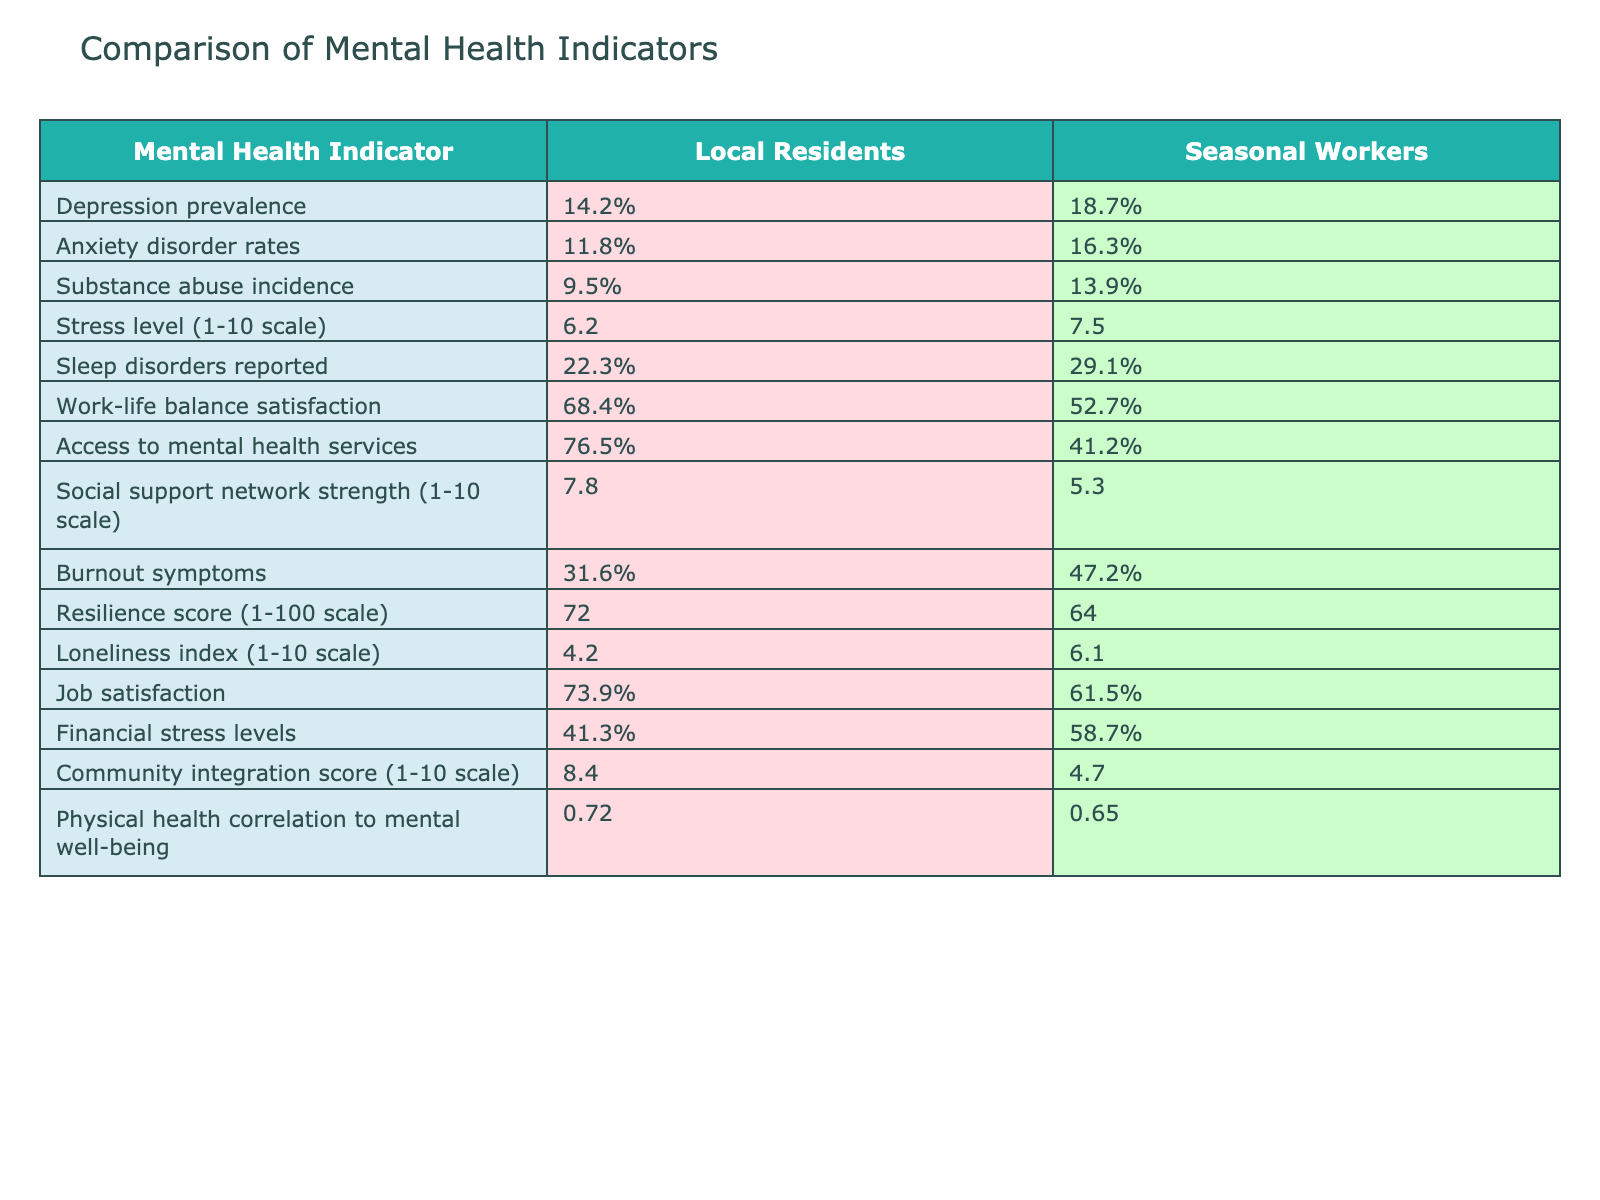What is the prevalence of depression among local residents? The table states that the prevalence of depression among local residents is 14.2%.
Answer: 14.2% What percentage of seasonal workers report sleep disorders? According to the table, 29.1% of seasonal workers report sleep disorders.
Answer: 29.1% Is the anxiety disorder rate higher for seasonal workers than local residents? Yes, seasonal workers have an anxiety disorder rate of 16.3%, which is higher than the 11.8% for local residents.
Answer: Yes What is the difference in work-life balance satisfaction between local residents and seasonal workers? Local residents have a work-life balance satisfaction of 68.4%, while seasonal workers have 52.7%. The difference is 68.4% - 52.7% = 15.7%.
Answer: 15.7% What is the average stress level for both groups? The average stress level for local residents is 6.2 and for seasonal workers is 7.5. To find the average, (6.2 + 7.5) / 2 = 6.85.
Answer: 6.85 Which group has a stronger social support network? The table displays a social support network strength of 7.8 for local residents and 5.3 for seasonal workers, indicating that local residents have a stronger network.
Answer: Local residents How much higher is the burnout symptom percentage in seasonal workers compared to local residents? The burnout symptoms percentage is 31.6% for local residents and 47.2% for seasonal workers. The increase is 47.2% - 31.6% = 15.6%.
Answer: 15.6% What is the correlation of physical health to mental well-being for local residents and seasonal workers? The physical health correlation to mental well-being is 0.72 for local residents and 0.65 for seasonal workers. This shows a higher correlation for local residents.
Answer: Local residents Do more seasonal workers have access to mental health services compared to local residents? No, 41.2% of seasonal workers have access to mental health services, which is significantly lower than 76.5% for local residents.
Answer: No What is the loneliness index for seasonal workers, and how does it compare to local residents? The loneliness index for seasonal workers is 6.1, while for local residents, it is 4.2. This indicates that seasonal workers experience higher loneliness.
Answer: Higher loneliness for seasonal workers 